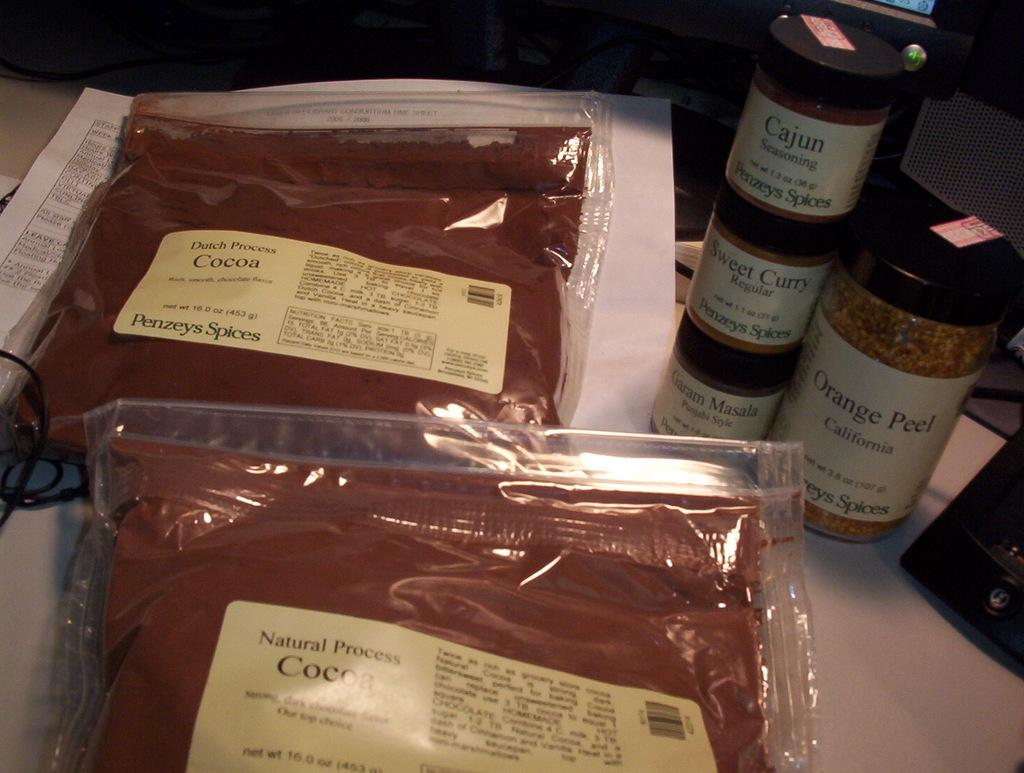Provide a one-sentence caption for the provided image. Natural Process cocoa in a pack and seasoning in a bottle. 